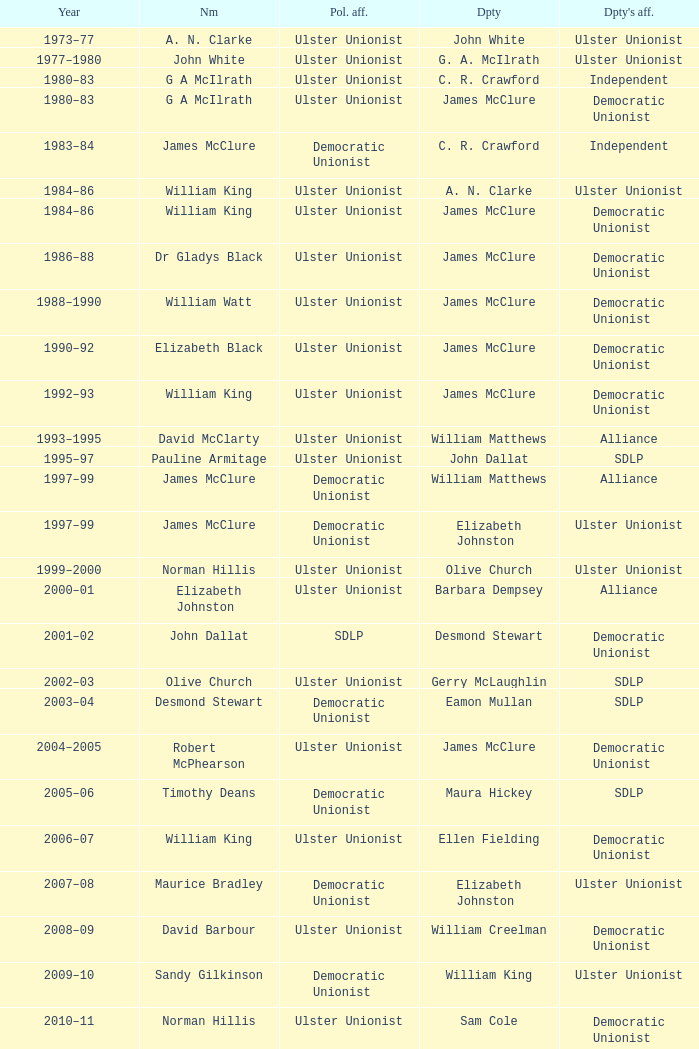Would you be able to parse every entry in this table? {'header': ['Year', 'Nm', 'Pol. aff.', 'Dpty', "Dpty's aff."], 'rows': [['1973–77', 'A. N. Clarke', 'Ulster Unionist', 'John White', 'Ulster Unionist'], ['1977–1980', 'John White', 'Ulster Unionist', 'G. A. McIlrath', 'Ulster Unionist'], ['1980–83', 'G A McIlrath', 'Ulster Unionist', 'C. R. Crawford', 'Independent'], ['1980–83', 'G A McIlrath', 'Ulster Unionist', 'James McClure', 'Democratic Unionist'], ['1983–84', 'James McClure', 'Democratic Unionist', 'C. R. Crawford', 'Independent'], ['1984–86', 'William King', 'Ulster Unionist', 'A. N. Clarke', 'Ulster Unionist'], ['1984–86', 'William King', 'Ulster Unionist', 'James McClure', 'Democratic Unionist'], ['1986–88', 'Dr Gladys Black', 'Ulster Unionist', 'James McClure', 'Democratic Unionist'], ['1988–1990', 'William Watt', 'Ulster Unionist', 'James McClure', 'Democratic Unionist'], ['1990–92', 'Elizabeth Black', 'Ulster Unionist', 'James McClure', 'Democratic Unionist'], ['1992–93', 'William King', 'Ulster Unionist', 'James McClure', 'Democratic Unionist'], ['1993–1995', 'David McClarty', 'Ulster Unionist', 'William Matthews', 'Alliance'], ['1995–97', 'Pauline Armitage', 'Ulster Unionist', 'John Dallat', 'SDLP'], ['1997–99', 'James McClure', 'Democratic Unionist', 'William Matthews', 'Alliance'], ['1997–99', 'James McClure', 'Democratic Unionist', 'Elizabeth Johnston', 'Ulster Unionist'], ['1999–2000', 'Norman Hillis', 'Ulster Unionist', 'Olive Church', 'Ulster Unionist'], ['2000–01', 'Elizabeth Johnston', 'Ulster Unionist', 'Barbara Dempsey', 'Alliance'], ['2001–02', 'John Dallat', 'SDLP', 'Desmond Stewart', 'Democratic Unionist'], ['2002–03', 'Olive Church', 'Ulster Unionist', 'Gerry McLaughlin', 'SDLP'], ['2003–04', 'Desmond Stewart', 'Democratic Unionist', 'Eamon Mullan', 'SDLP'], ['2004–2005', 'Robert McPhearson', 'Ulster Unionist', 'James McClure', 'Democratic Unionist'], ['2005–06', 'Timothy Deans', 'Democratic Unionist', 'Maura Hickey', 'SDLP'], ['2006–07', 'William King', 'Ulster Unionist', 'Ellen Fielding', 'Democratic Unionist'], ['2007–08', 'Maurice Bradley', 'Democratic Unionist', 'Elizabeth Johnston', 'Ulster Unionist'], ['2008–09', 'David Barbour', 'Ulster Unionist', 'William Creelman', 'Democratic Unionist'], ['2009–10', 'Sandy Gilkinson', 'Democratic Unionist', 'William King', 'Ulster Unionist'], ['2010–11', 'Norman Hillis', 'Ulster Unionist', 'Sam Cole', 'Democratic Unionist'], ['2011–12', 'Maurice Bradley', 'Democratic Unionist', 'William King', 'Ulster Unionist'], ['2012–13', 'Sam Cole', 'Democratic Unionist', 'Maura Hickey', 'SDLP'], ['2013–14', 'David Harding', 'Ulster Unionist', 'Mark Fielding', 'Democratic Unionist']]} What Year was james mcclure Deputy, and the Name is robert mcphearson? 2004–2005. 